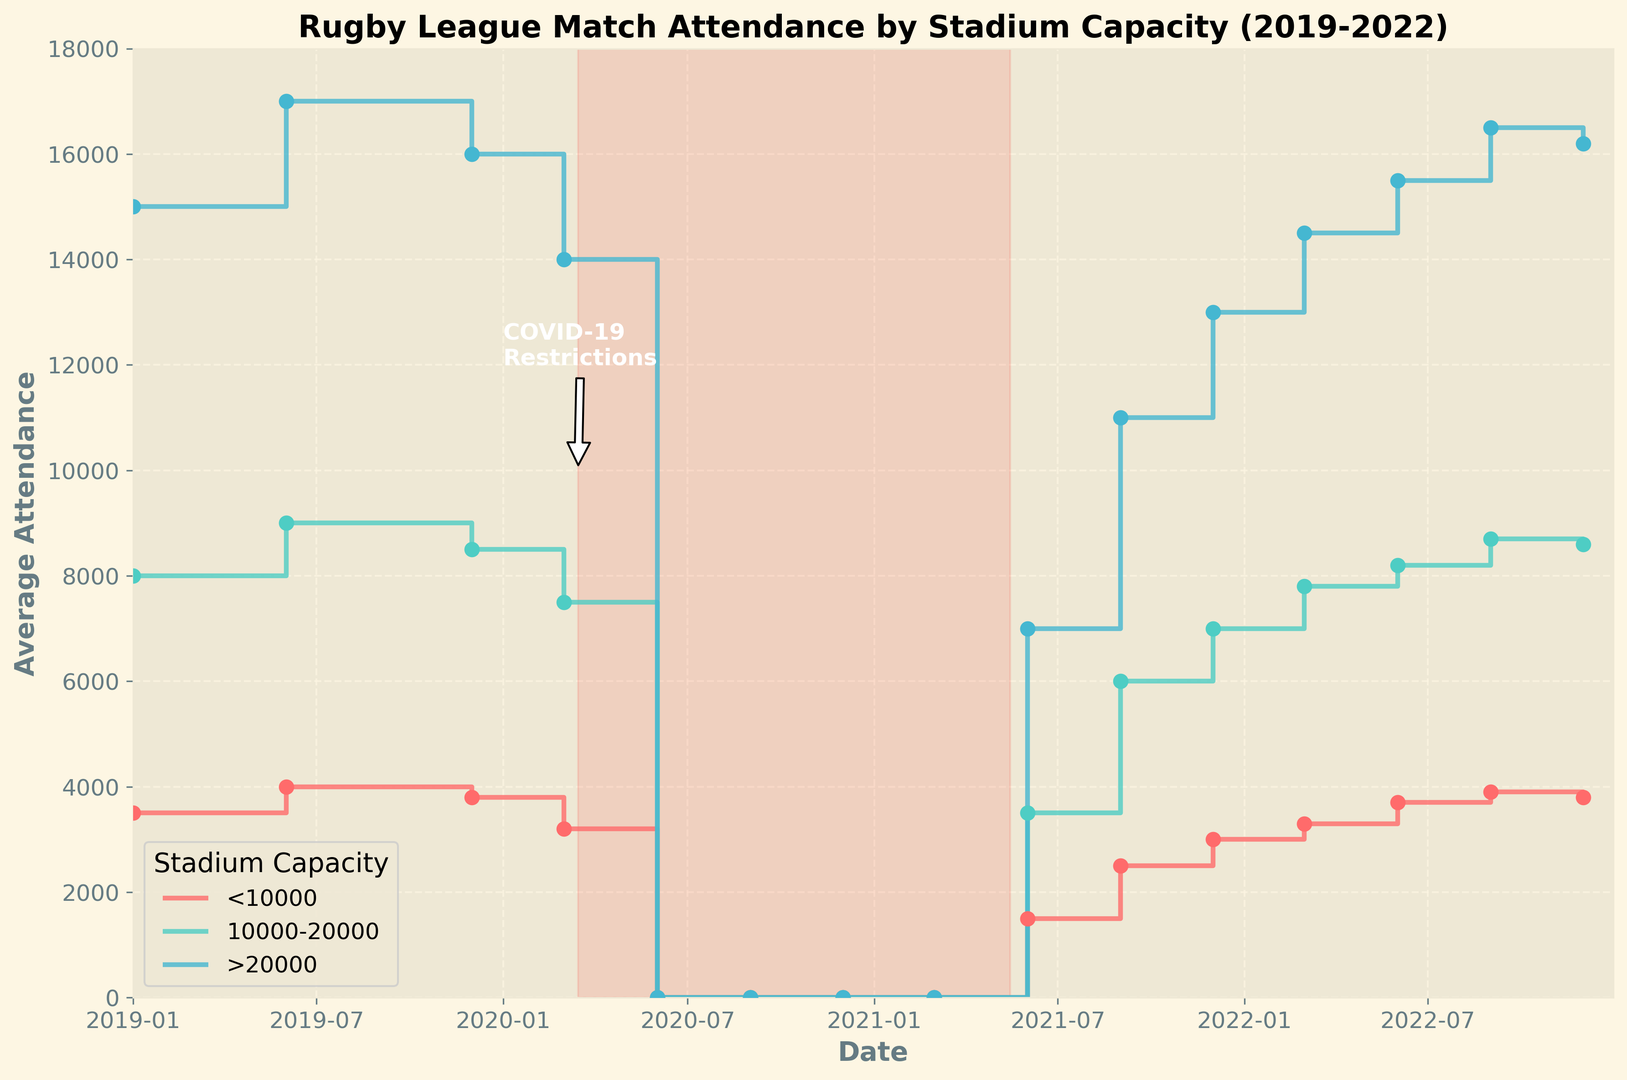What's the average attendance for stadiums with a capacity of 10000-20000 after COVID-19 restrictions were eased in June 2021? Locate the data points for the capacity category "10000-20000", specifically for June 2021, from which restrictions were eased. The attendance figure is labeled as 3500.
Answer: 3500 Which stadium capacity category showed the quickest recovery in attendance figures post-COVID-19 restrictions? Compare the rise in attendance figures from June 2021 onwards for the three stadium capacity categories. Stadiums with a capacity >20000 showed the highest increase in attendance from 7000 to 16500 by September 2022, indicating the quickest recovery.
Answer: >20000 How did average attendance for stadiums with less than 10000 capacity change from December 2019 to June 2020? In December 2019, the average attendance was 3800, and it dropped to 0 in June 2020 due to COVID-19 restrictions.
Answer: Dropped to 0 By December 2022, did any stadium capacity category return to pre-pandemic attendance levels, and if so, which one? Compare the attendance figures from December 2019 to December 2022 for all capacity categories. Stadiums with capacities 10000-20000 and >20000 returned to near pre-pandemic levels by December 2022 (around 8600 and 16200, respectively).
Answer: Yes, 10000-20000 and >20000 What marked differences can be observed in attendance across different stadium capacities during the peak COVID-19 restriction period? For all capacity categories (<10000, 10000-20000, >20000), the attendance figures from June 2020 to March 2021 were consistently 0 due to restrictions. This can be seen from the flatlines at zero for all categories.
Answer: Attendance was zero for all categories Compare attendance figures in December 2019 and December 2021 for stadiums with more than 20000 capacity. In December 2019, the attendance for >20000 capacity stadiums was 16000, whereas in December 2021, it had risen to 13000, lower than pre-pandemic levels.
Answer: 16000 in 2019, 13000 in 2021 How did the attendance for the stadium capacity of <10000 in June 2022 compare to the attendance figures in June 2019? In June 2019, the attendance for <10000 capacity stadiums was 4000. In June 2022, the attendance for the same capacity was 3700, showing a slight decrease.
Answer: Slightly decreased, 4000 to 3700 What visual marks indicate the period of COVID-19 restrictions on the plot? There is an annotation labeled "COVID-19 Restrictions" with an arrow pointing to the timeline from March 2020 to May 2021, along with a shaded red area covering this period on the X-axis, indicating the restrictions duration.
Answer: Annotation and shaded red area For the capacity category >20000, when did attendance first reach at least 15000 after the restrictions? Locate the attendance figures post-easing of restrictions for the capacity category >20000. Attendance reached 15000 first in the month of March 2022.
Answer: March 2022 